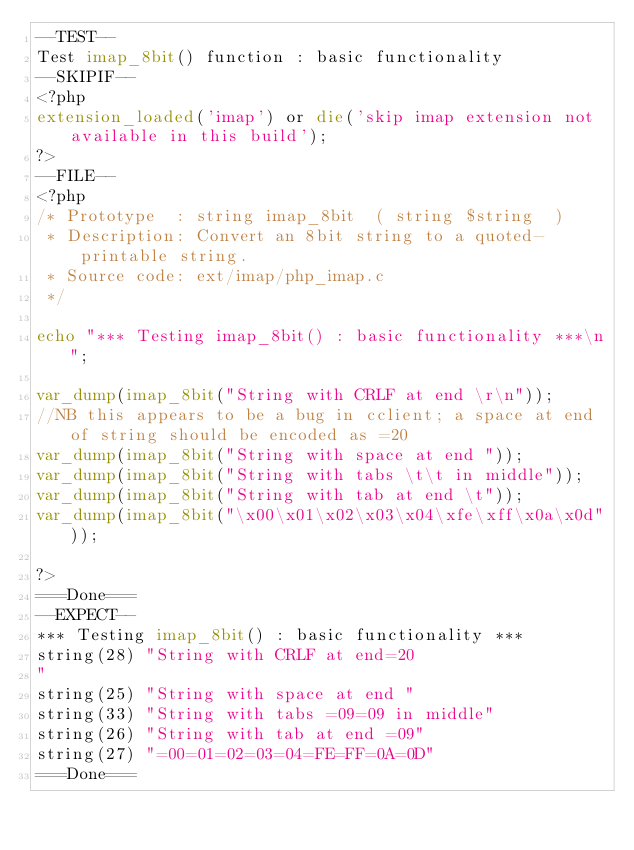<code> <loc_0><loc_0><loc_500><loc_500><_PHP_>--TEST--
Test imap_8bit() function : basic functionality
--SKIPIF--
<?php
extension_loaded('imap') or die('skip imap extension not available in this build');
?>
--FILE--
<?php
/* Prototype  : string imap_8bit  ( string $string  )
 * Description: Convert an 8bit string to a quoted-printable string.
 * Source code: ext/imap/php_imap.c
 */

echo "*** Testing imap_8bit() : basic functionality ***\n";

var_dump(imap_8bit("String with CRLF at end \r\n"));
//NB this appears to be a bug in cclient; a space at end of string should be encoded as =20
var_dump(imap_8bit("String with space at end "));
var_dump(imap_8bit("String with tabs \t\t in middle"));
var_dump(imap_8bit("String with tab at end \t"));
var_dump(imap_8bit("\x00\x01\x02\x03\x04\xfe\xff\x0a\x0d"));

?>
===Done===
--EXPECT--
*** Testing imap_8bit() : basic functionality ***
string(28) "String with CRLF at end=20
"
string(25) "String with space at end "
string(33) "String with tabs =09=09 in middle"
string(26) "String with tab at end =09"
string(27) "=00=01=02=03=04=FE=FF=0A=0D"
===Done===
</code> 